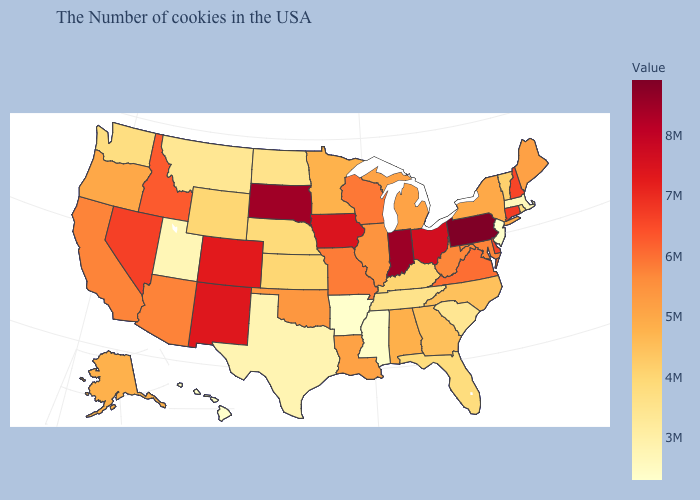Does Maryland have a higher value than New Mexico?
Answer briefly. No. Among the states that border West Virginia , does Pennsylvania have the highest value?
Write a very short answer. Yes. Does Florida have a lower value than Texas?
Write a very short answer. No. Which states have the highest value in the USA?
Answer briefly. Pennsylvania. Among the states that border Illinois , which have the lowest value?
Write a very short answer. Kentucky. Among the states that border Mississippi , does Louisiana have the lowest value?
Answer briefly. No. Does Louisiana have a higher value than Idaho?
Answer briefly. No. Which states have the highest value in the USA?
Short answer required. Pennsylvania. 